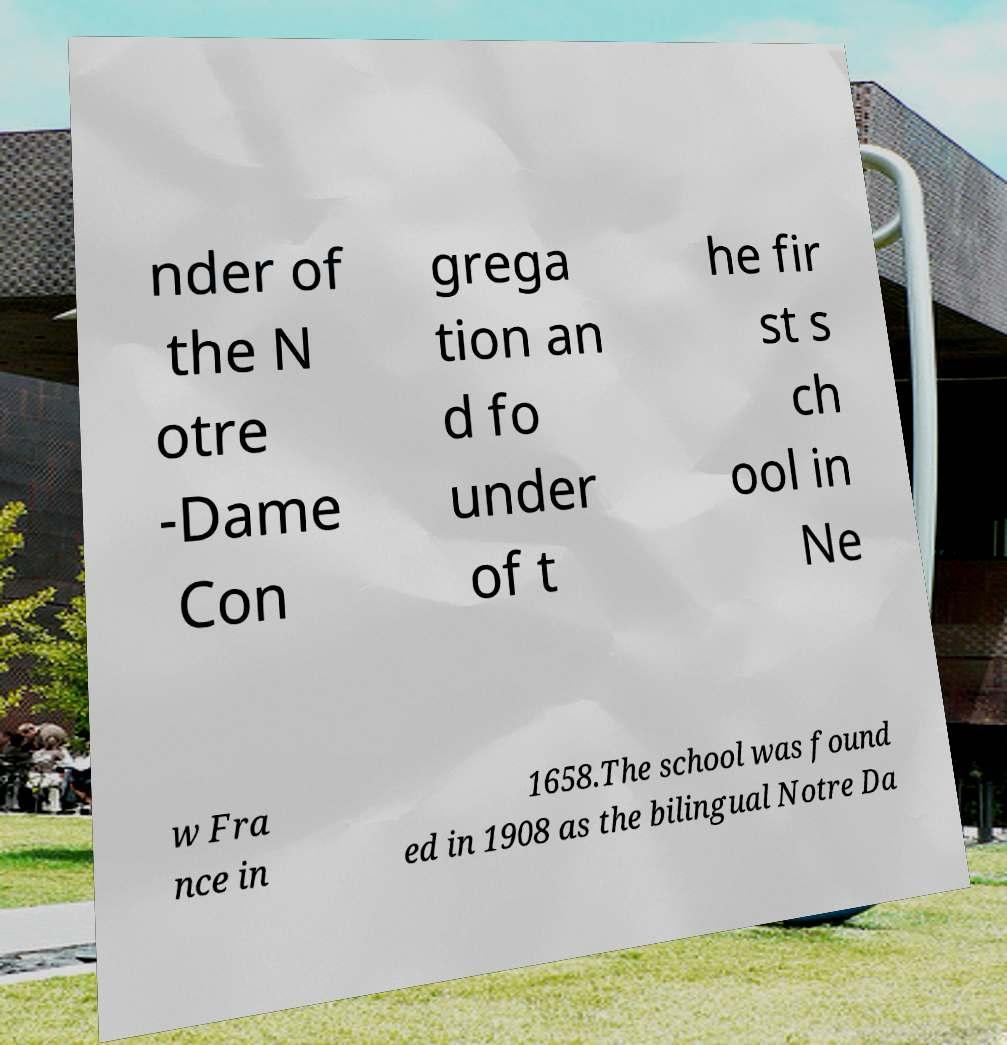Could you extract and type out the text from this image? nder of the N otre -Dame Con grega tion an d fo under of t he fir st s ch ool in Ne w Fra nce in 1658.The school was found ed in 1908 as the bilingual Notre Da 